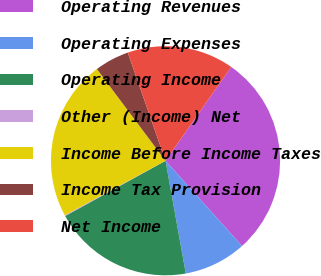Convert chart to OTSL. <chart><loc_0><loc_0><loc_500><loc_500><pie_chart><fcel>Operating Revenues<fcel>Operating Expenses<fcel>Operating Income<fcel>Other (Income) Net<fcel>Income Before Income Taxes<fcel>Income Tax Provision<fcel>Net Income<nl><fcel>28.63%<fcel>8.81%<fcel>19.82%<fcel>0.12%<fcel>22.67%<fcel>4.88%<fcel>15.06%<nl></chart> 